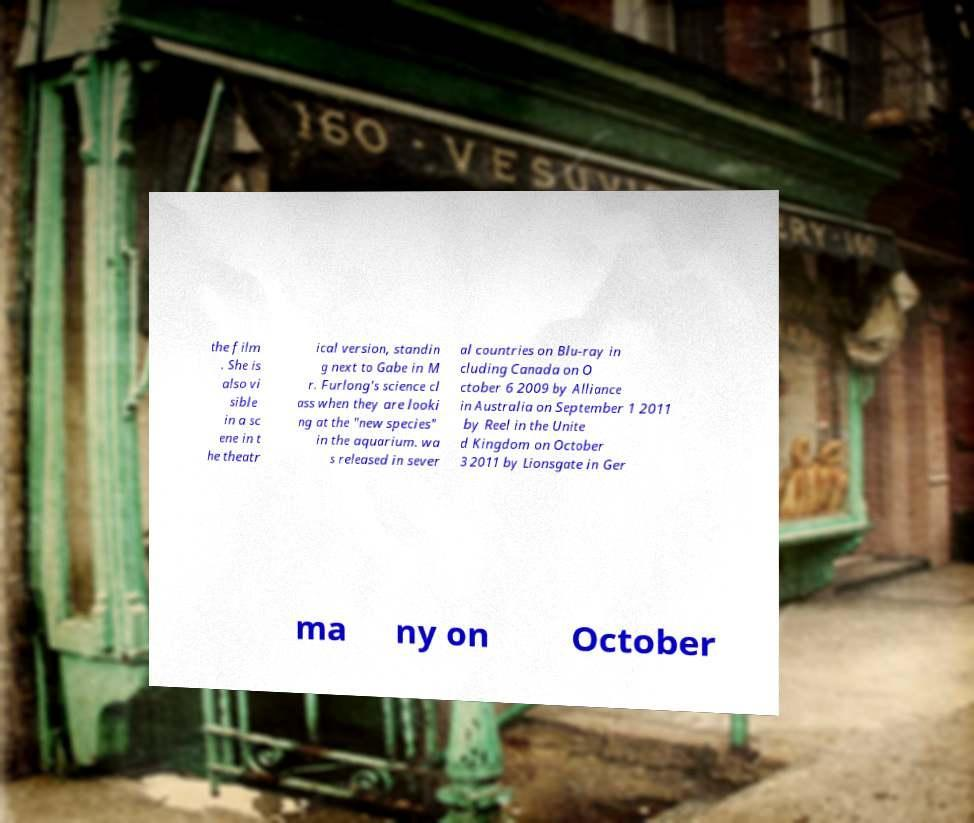What messages or text are displayed in this image? I need them in a readable, typed format. the film . She is also vi sible in a sc ene in t he theatr ical version, standin g next to Gabe in M r. Furlong's science cl ass when they are looki ng at the "new species" in the aquarium. wa s released in sever al countries on Blu-ray in cluding Canada on O ctober 6 2009 by Alliance in Australia on September 1 2011 by Reel in the Unite d Kingdom on October 3 2011 by Lionsgate in Ger ma ny on October 